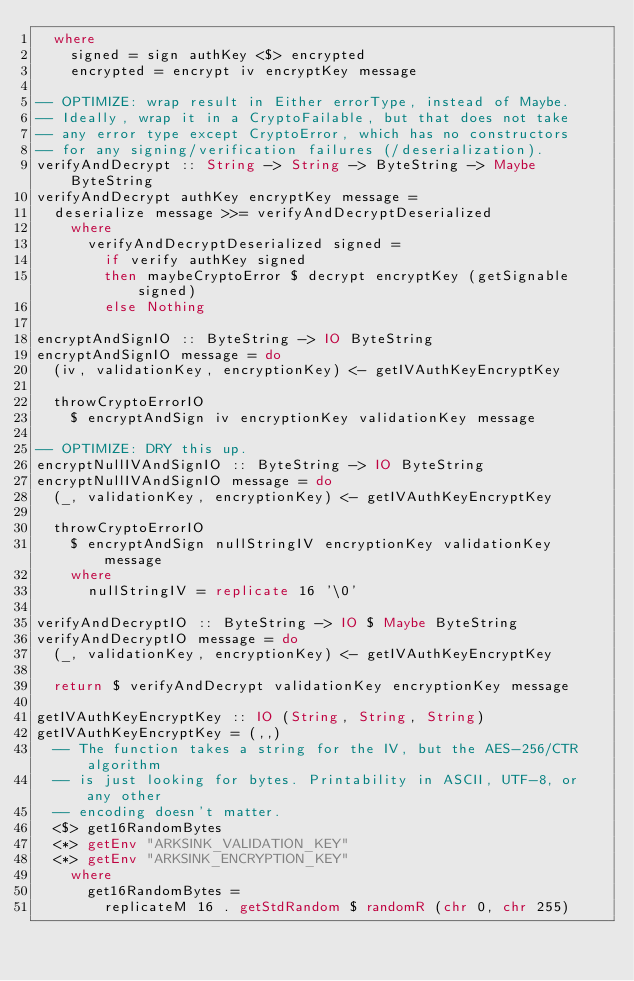<code> <loc_0><loc_0><loc_500><loc_500><_Haskell_>  where
    signed = sign authKey <$> encrypted
    encrypted = encrypt iv encryptKey message

-- OPTIMIZE: wrap result in Either errorType, instead of Maybe.
-- Ideally, wrap it in a CryptoFailable, but that does not take
-- any error type except CryptoError, which has no constructors
-- for any signing/verification failures (/deserialization).
verifyAndDecrypt :: String -> String -> ByteString -> Maybe ByteString
verifyAndDecrypt authKey encryptKey message =
  deserialize message >>= verifyAndDecryptDeserialized
    where
      verifyAndDecryptDeserialized signed = 
        if verify authKey signed
        then maybeCryptoError $ decrypt encryptKey (getSignable signed)
        else Nothing

encryptAndSignIO :: ByteString -> IO ByteString
encryptAndSignIO message = do
  (iv, validationKey, encryptionKey) <- getIVAuthKeyEncryptKey

  throwCryptoErrorIO
    $ encryptAndSign iv encryptionKey validationKey message

-- OPTIMIZE: DRY this up.
encryptNullIVAndSignIO :: ByteString -> IO ByteString
encryptNullIVAndSignIO message = do
  (_, validationKey, encryptionKey) <- getIVAuthKeyEncryptKey

  throwCryptoErrorIO
    $ encryptAndSign nullStringIV encryptionKey validationKey message
    where
      nullStringIV = replicate 16 '\0'

verifyAndDecryptIO :: ByteString -> IO $ Maybe ByteString
verifyAndDecryptIO message = do
  (_, validationKey, encryptionKey) <- getIVAuthKeyEncryptKey

  return $ verifyAndDecrypt validationKey encryptionKey message

getIVAuthKeyEncryptKey :: IO (String, String, String)
getIVAuthKeyEncryptKey = (,,)
  -- The function takes a string for the IV, but the AES-256/CTR algorithm
  -- is just looking for bytes. Printability in ASCII, UTF-8, or any other
  -- encoding doesn't matter.
  <$> get16RandomBytes
  <*> getEnv "ARKSINK_VALIDATION_KEY"
  <*> getEnv "ARKSINK_ENCRYPTION_KEY"
    where
      get16RandomBytes =
        replicateM 16 . getStdRandom $ randomR (chr 0, chr 255)
</code> 